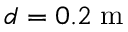<formula> <loc_0><loc_0><loc_500><loc_500>d = 0 . 2 \, m</formula> 